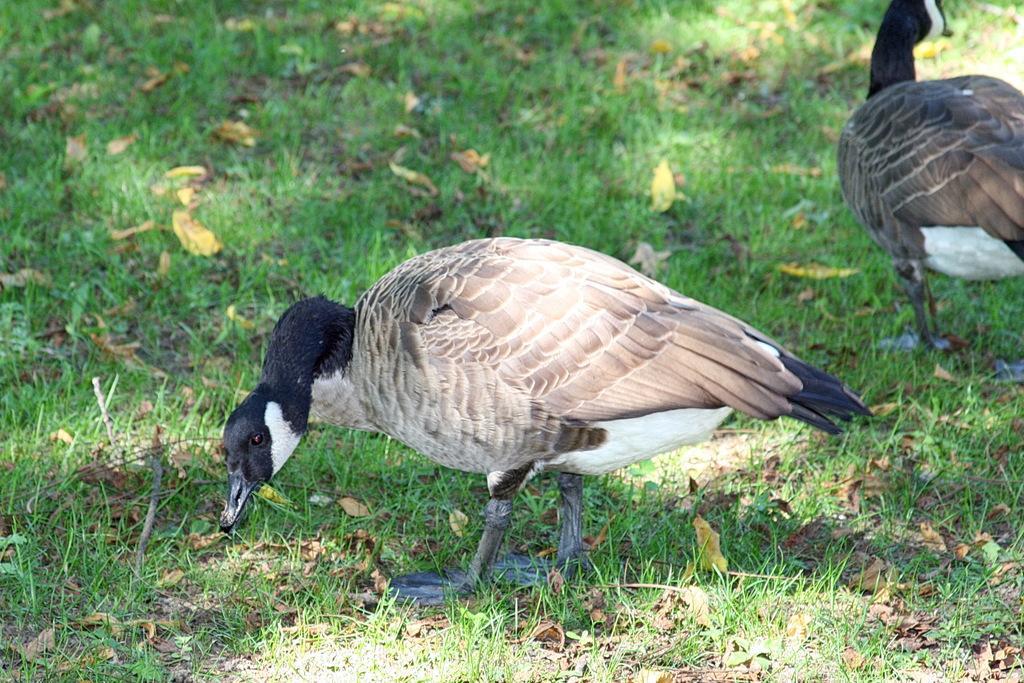Can you describe this image briefly? In this image we can see two birds on the ground. We can also see some grass and dried leaves. 